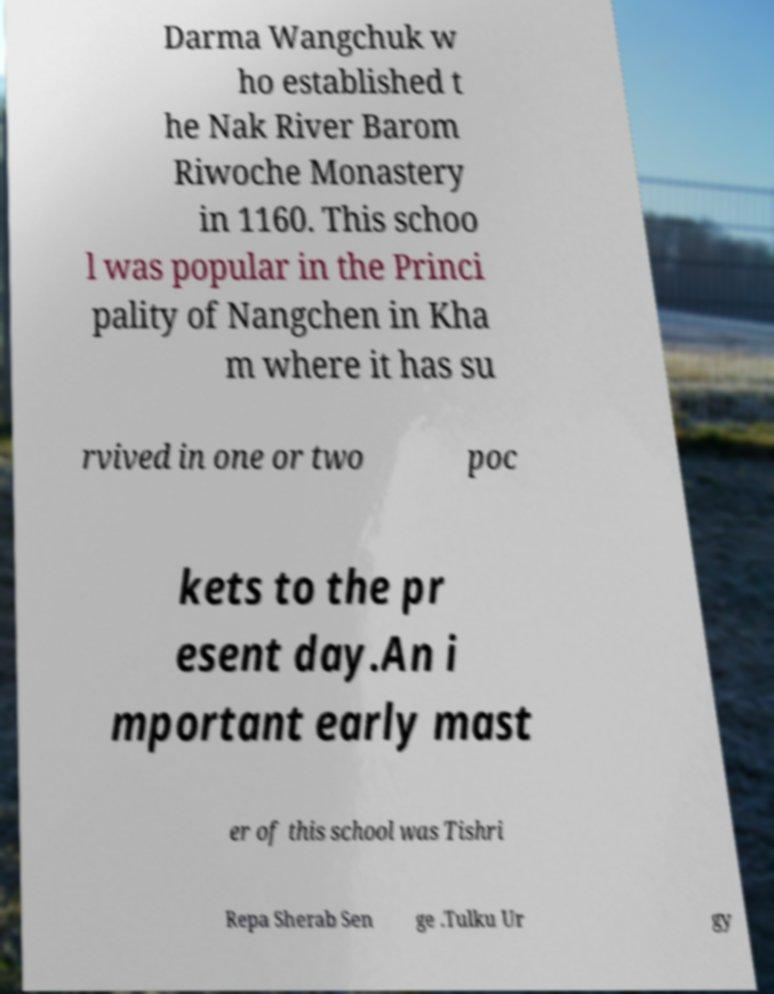Can you accurately transcribe the text from the provided image for me? Darma Wangchuk w ho established t he Nak River Barom Riwoche Monastery in 1160. This schoo l was popular in the Princi pality of Nangchen in Kha m where it has su rvived in one or two poc kets to the pr esent day.An i mportant early mast er of this school was Tishri Repa Sherab Sen ge .Tulku Ur gy 